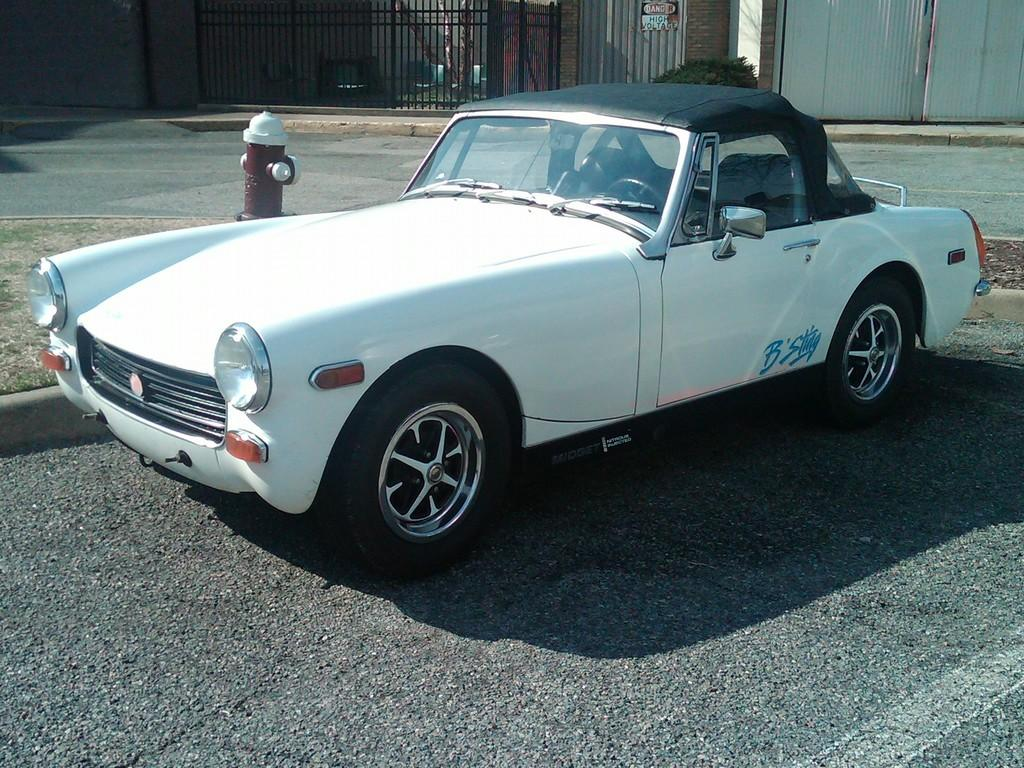What type of motor vehicle is on the road in the image? The specific type of motor vehicle is not mentioned, but there is a motor vehicle on the road in the image. What is the purpose of the hydrant in the image? The hydrant is likely for firefighting purposes, but its specific use is not mentioned in the image. What type of vegetation is present in the image? There are bushes in the image. What type of structures are visible in the image? There are buildings in the image. What type of cooking equipment is present in the image? There are grills in the image. What type of stocking is hanging on the hydrant in the image? There is no stocking hanging on the hydrant in the image. What type of sand can be seen on the grills in the image? There is no sand present in the image, and the grills are not mentioned to have any sand on them. 